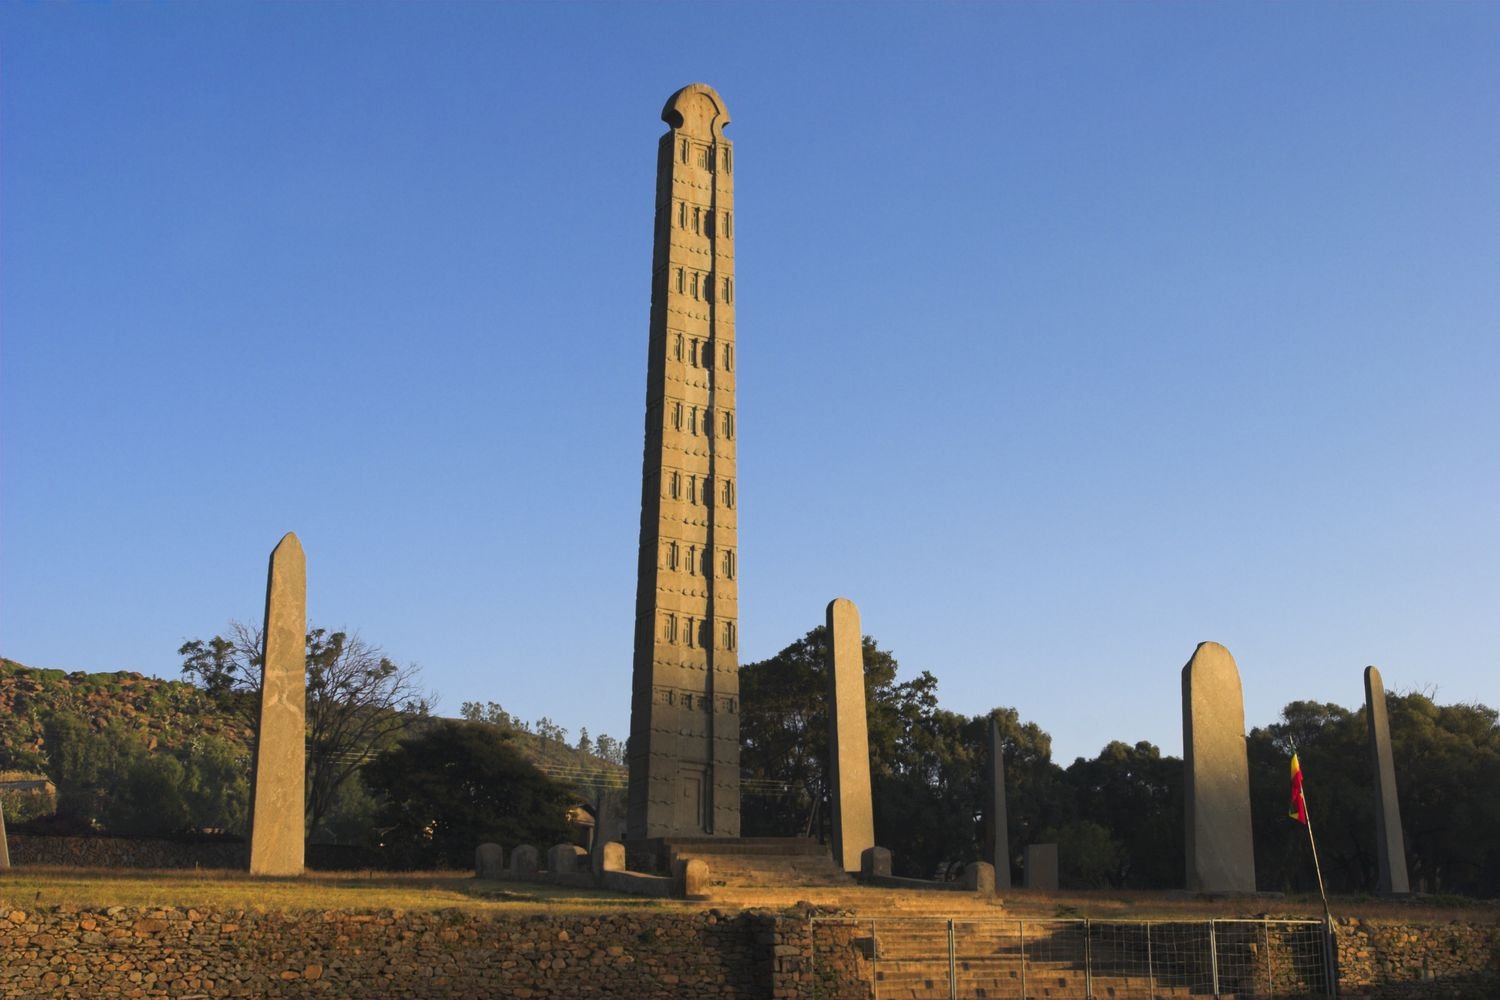If this obelisk were part of a fantasy world, what kind of magical properties might it possess? In a fantasy world, the Obelisk of Axum would be a mystical artifact of immense power. Rooted in ancient magic, it could act as a conduit for celestial energies, channeling wisdom and vitality to those deemed worthy. The carvings on the obelisk would glow with ethereal light during celestial events, such as solstices and lunar eclipses, and could unlock hidden portals to other dimensions. It might possess the ability to manipulate time, allowing brief glimpses into the past and future. Additionally, the obelisk could serve as a guardian, warding off dark forces with a protective aura that emanates from the semi-circular design at its peak, imbuing the land with harmony and balance. Encrypted within its granite structure might be ancient spells only accessible through an incantation known to the high priests of old, making it both a treasure and a responsibility to safeguard. Create a short story involving this obelisk in a science fiction setting. In the year 3025, interstellar archaeologist Dr. Lira Xandros landed on the ancient grounds of Aksum. Her mission: to uncover the secrets of the Obelisk of Axum, believed to be a remnant of an extraterrestrial civilization. Equipped with advanced tech, Lira discovered that the obelisk was a sophisticated relay station, able to transmit messages across galaxies. Hidden sensors within the false doors responded to her touch, activating holographic displays that revealed the obelisk’s role in a long-lost intergalactic network. As she unraveled encrypted data, Lira uncovered coordinates to a distant star system, suggesting that the ancients of Aksum were descendants of starfarers who settled Earth millennia ago. The obelisk, a relic of forgotten advanced technology, held the key to reconnecting humanity with its cosmic origins. As night fell, the obelisk began to hum, and its carvings glowed anew, casting an azure light into the sky, signaling the start of humanity’s next voyage among the stars. 